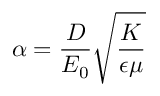Convert formula to latex. <formula><loc_0><loc_0><loc_500><loc_500>\alpha = \frac { D } { E _ { 0 } } \sqrt { \frac { K } { \epsilon \mu } }</formula> 